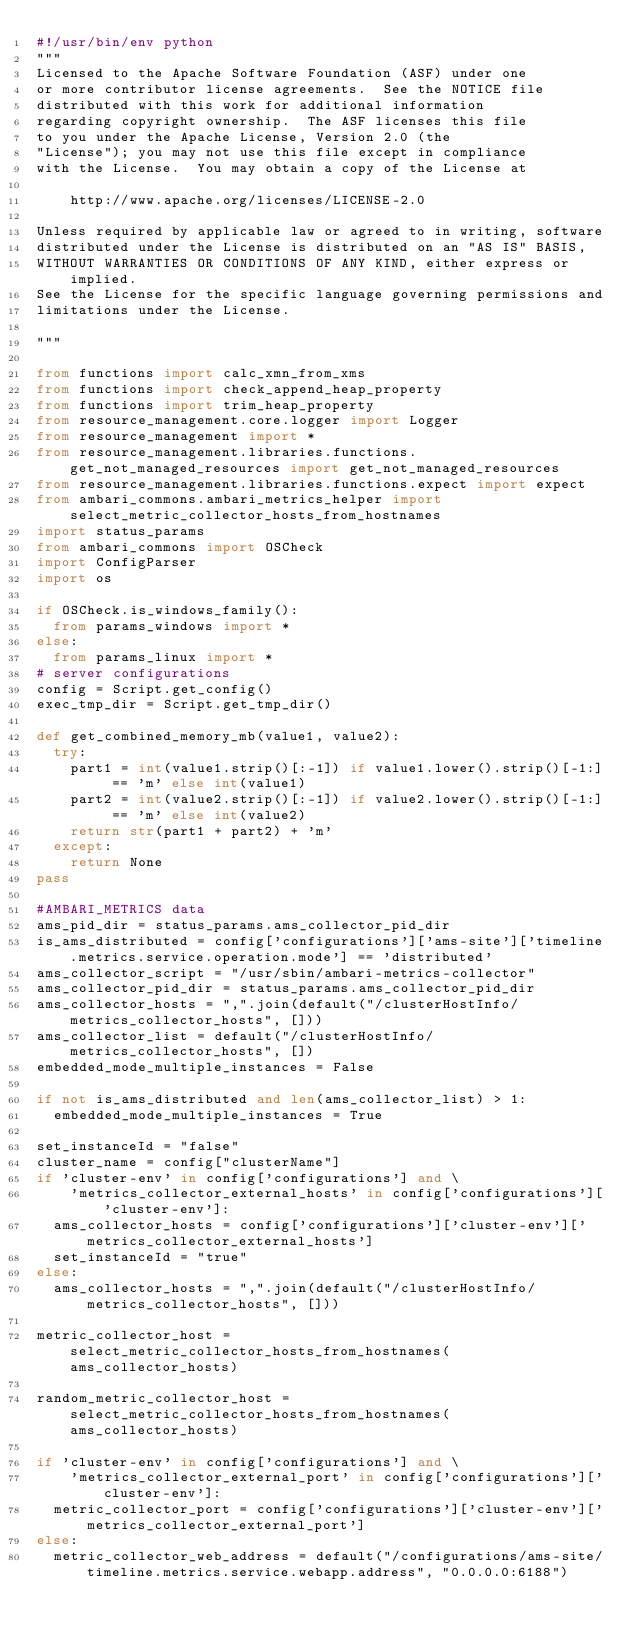Convert code to text. <code><loc_0><loc_0><loc_500><loc_500><_Python_>#!/usr/bin/env python
"""
Licensed to the Apache Software Foundation (ASF) under one
or more contributor license agreements.  See the NOTICE file
distributed with this work for additional information
regarding copyright ownership.  The ASF licenses this file
to you under the Apache License, Version 2.0 (the
"License"); you may not use this file except in compliance
with the License.  You may obtain a copy of the License at

    http://www.apache.org/licenses/LICENSE-2.0

Unless required by applicable law or agreed to in writing, software
distributed under the License is distributed on an "AS IS" BASIS,
WITHOUT WARRANTIES OR CONDITIONS OF ANY KIND, either express or implied.
See the License for the specific language governing permissions and
limitations under the License.

"""

from functions import calc_xmn_from_xms
from functions import check_append_heap_property
from functions import trim_heap_property
from resource_management.core.logger import Logger
from resource_management import *
from resource_management.libraries.functions.get_not_managed_resources import get_not_managed_resources
from resource_management.libraries.functions.expect import expect
from ambari_commons.ambari_metrics_helper import select_metric_collector_hosts_from_hostnames
import status_params
from ambari_commons import OSCheck
import ConfigParser
import os

if OSCheck.is_windows_family():
  from params_windows import *
else:
  from params_linux import *
# server configurations
config = Script.get_config()
exec_tmp_dir = Script.get_tmp_dir()

def get_combined_memory_mb(value1, value2):
  try:
    part1 = int(value1.strip()[:-1]) if value1.lower().strip()[-1:] == 'm' else int(value1)
    part2 = int(value2.strip()[:-1]) if value2.lower().strip()[-1:] == 'm' else int(value2)
    return str(part1 + part2) + 'm'
  except:
    return None
pass

#AMBARI_METRICS data
ams_pid_dir = status_params.ams_collector_pid_dir
is_ams_distributed = config['configurations']['ams-site']['timeline.metrics.service.operation.mode'] == 'distributed'
ams_collector_script = "/usr/sbin/ambari-metrics-collector"
ams_collector_pid_dir = status_params.ams_collector_pid_dir
ams_collector_hosts = ",".join(default("/clusterHostInfo/metrics_collector_hosts", []))
ams_collector_list = default("/clusterHostInfo/metrics_collector_hosts", [])
embedded_mode_multiple_instances = False

if not is_ams_distributed and len(ams_collector_list) > 1:
  embedded_mode_multiple_instances = True

set_instanceId = "false"
cluster_name = config["clusterName"]
if 'cluster-env' in config['configurations'] and \
    'metrics_collector_external_hosts' in config['configurations']['cluster-env']:
  ams_collector_hosts = config['configurations']['cluster-env']['metrics_collector_external_hosts']
  set_instanceId = "true"
else:
  ams_collector_hosts = ",".join(default("/clusterHostInfo/metrics_collector_hosts", []))

metric_collector_host = select_metric_collector_hosts_from_hostnames(ams_collector_hosts)

random_metric_collector_host = select_metric_collector_hosts_from_hostnames(ams_collector_hosts)

if 'cluster-env' in config['configurations'] and \
    'metrics_collector_external_port' in config['configurations']['cluster-env']:
  metric_collector_port = config['configurations']['cluster-env']['metrics_collector_external_port']
else:
  metric_collector_web_address = default("/configurations/ams-site/timeline.metrics.service.webapp.address", "0.0.0.0:6188")</code> 